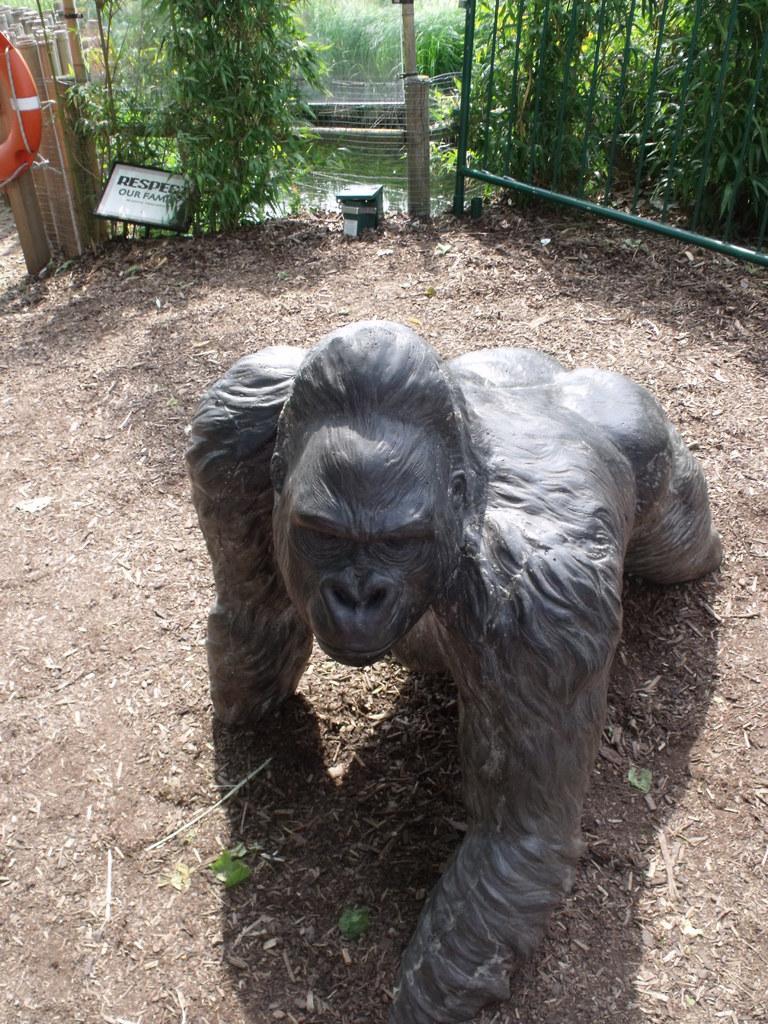In one or two sentences, can you explain what this image depicts? In this image I can see the animal statue and the statue is in black color, background I can see a board in white color, few trees in green color and I can also see the water. 